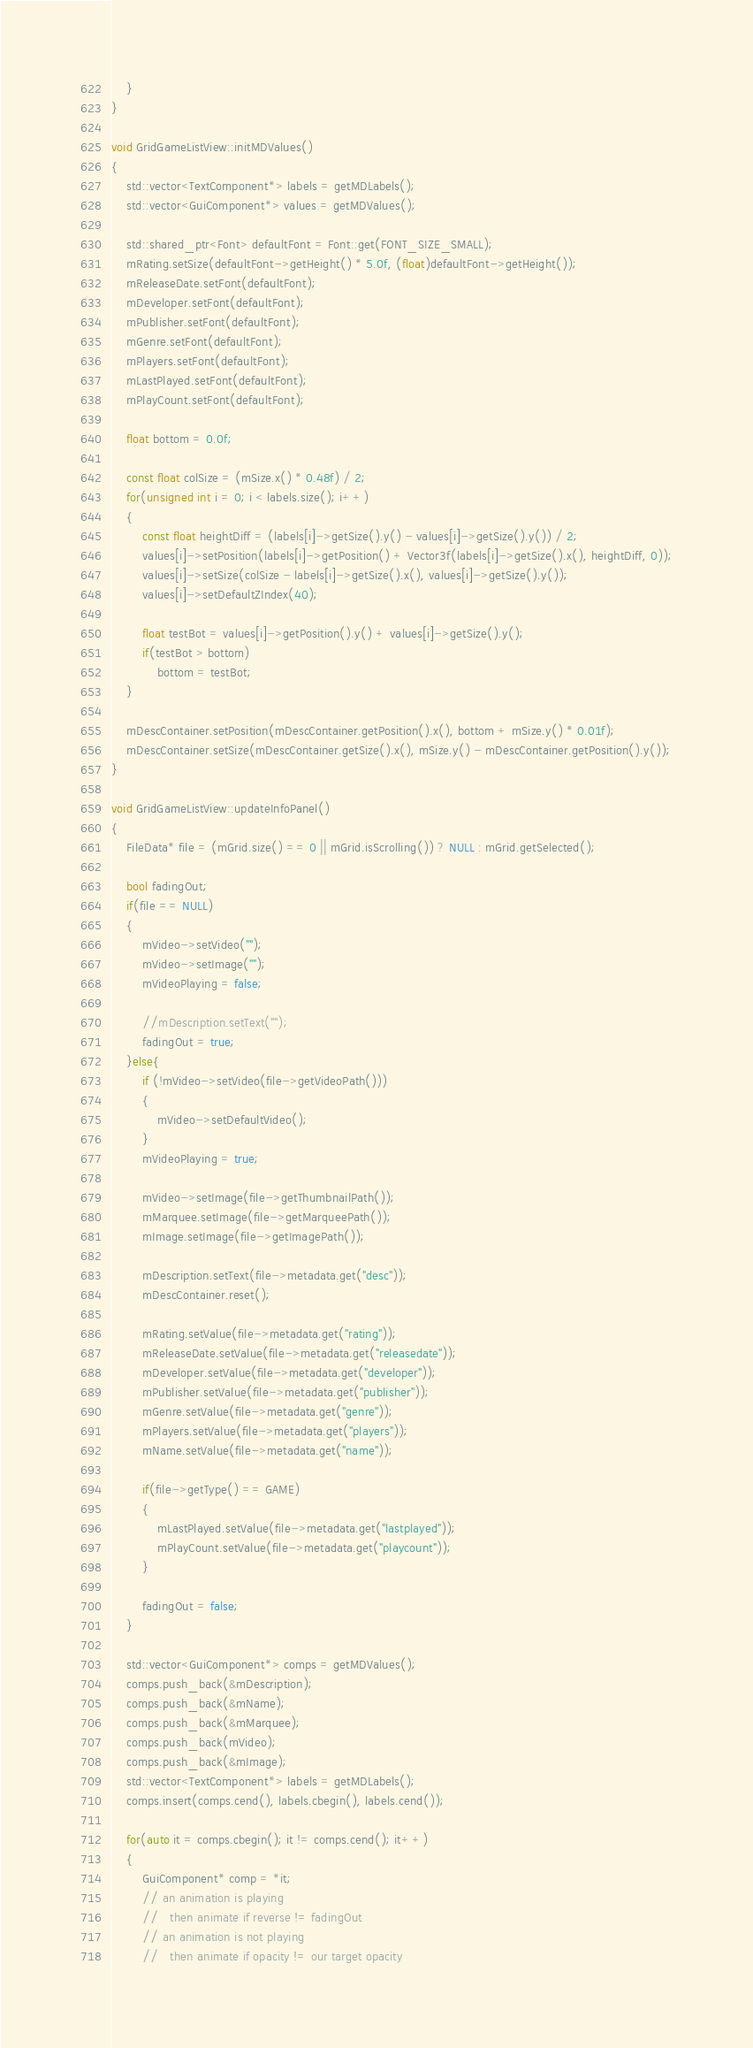Convert code to text. <code><loc_0><loc_0><loc_500><loc_500><_C++_>	}
}

void GridGameListView::initMDValues()
{
	std::vector<TextComponent*> labels = getMDLabels();
	std::vector<GuiComponent*> values = getMDValues();

	std::shared_ptr<Font> defaultFont = Font::get(FONT_SIZE_SMALL);
	mRating.setSize(defaultFont->getHeight() * 5.0f, (float)defaultFont->getHeight());
	mReleaseDate.setFont(defaultFont);
	mDeveloper.setFont(defaultFont);
	mPublisher.setFont(defaultFont);
	mGenre.setFont(defaultFont);
	mPlayers.setFont(defaultFont);
	mLastPlayed.setFont(defaultFont);
	mPlayCount.setFont(defaultFont);

	float bottom = 0.0f;

	const float colSize = (mSize.x() * 0.48f) / 2;
	for(unsigned int i = 0; i < labels.size(); i++)
	{
		const float heightDiff = (labels[i]->getSize().y() - values[i]->getSize().y()) / 2;
		values[i]->setPosition(labels[i]->getPosition() + Vector3f(labels[i]->getSize().x(), heightDiff, 0));
		values[i]->setSize(colSize - labels[i]->getSize().x(), values[i]->getSize().y());
		values[i]->setDefaultZIndex(40);

		float testBot = values[i]->getPosition().y() + values[i]->getSize().y();
		if(testBot > bottom)
			bottom = testBot;
	}

	mDescContainer.setPosition(mDescContainer.getPosition().x(), bottom + mSize.y() * 0.01f);
	mDescContainer.setSize(mDescContainer.getSize().x(), mSize.y() - mDescContainer.getPosition().y());
}

void GridGameListView::updateInfoPanel()
{
	FileData* file = (mGrid.size() == 0 || mGrid.isScrolling()) ? NULL : mGrid.getSelected();

	bool fadingOut;
	if(file == NULL)
	{
		mVideo->setVideo("");
		mVideo->setImage("");
		mVideoPlaying = false;

		//mDescription.setText("");
		fadingOut = true;
	}else{
		if (!mVideo->setVideo(file->getVideoPath()))
		{
			mVideo->setDefaultVideo();
		}
		mVideoPlaying = true;

		mVideo->setImage(file->getThumbnailPath());
		mMarquee.setImage(file->getMarqueePath());
		mImage.setImage(file->getImagePath());

		mDescription.setText(file->metadata.get("desc"));
		mDescContainer.reset();

		mRating.setValue(file->metadata.get("rating"));
		mReleaseDate.setValue(file->metadata.get("releasedate"));
		mDeveloper.setValue(file->metadata.get("developer"));
		mPublisher.setValue(file->metadata.get("publisher"));
		mGenre.setValue(file->metadata.get("genre"));
		mPlayers.setValue(file->metadata.get("players"));
		mName.setValue(file->metadata.get("name"));

		if(file->getType() == GAME)
		{
			mLastPlayed.setValue(file->metadata.get("lastplayed"));
			mPlayCount.setValue(file->metadata.get("playcount"));
		}

		fadingOut = false;
	}

	std::vector<GuiComponent*> comps = getMDValues();
	comps.push_back(&mDescription);
	comps.push_back(&mName);
	comps.push_back(&mMarquee);
	comps.push_back(mVideo);
	comps.push_back(&mImage);
	std::vector<TextComponent*> labels = getMDLabels();
	comps.insert(comps.cend(), labels.cbegin(), labels.cend());

	for(auto it = comps.cbegin(); it != comps.cend(); it++)
	{
		GuiComponent* comp = *it;
		// an animation is playing
		//   then animate if reverse != fadingOut
		// an animation is not playing
		//   then animate if opacity != our target opacity</code> 